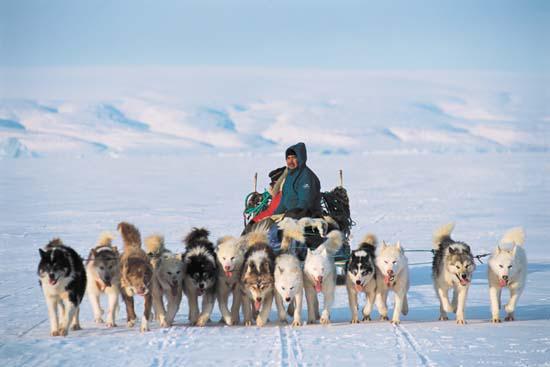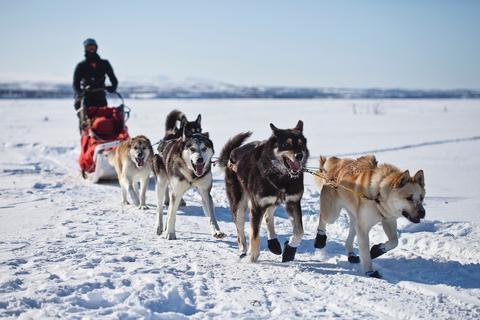The first image is the image on the left, the second image is the image on the right. For the images displayed, is the sentence "Some dogs are wearing booties." factually correct? Answer yes or no. Yes. 